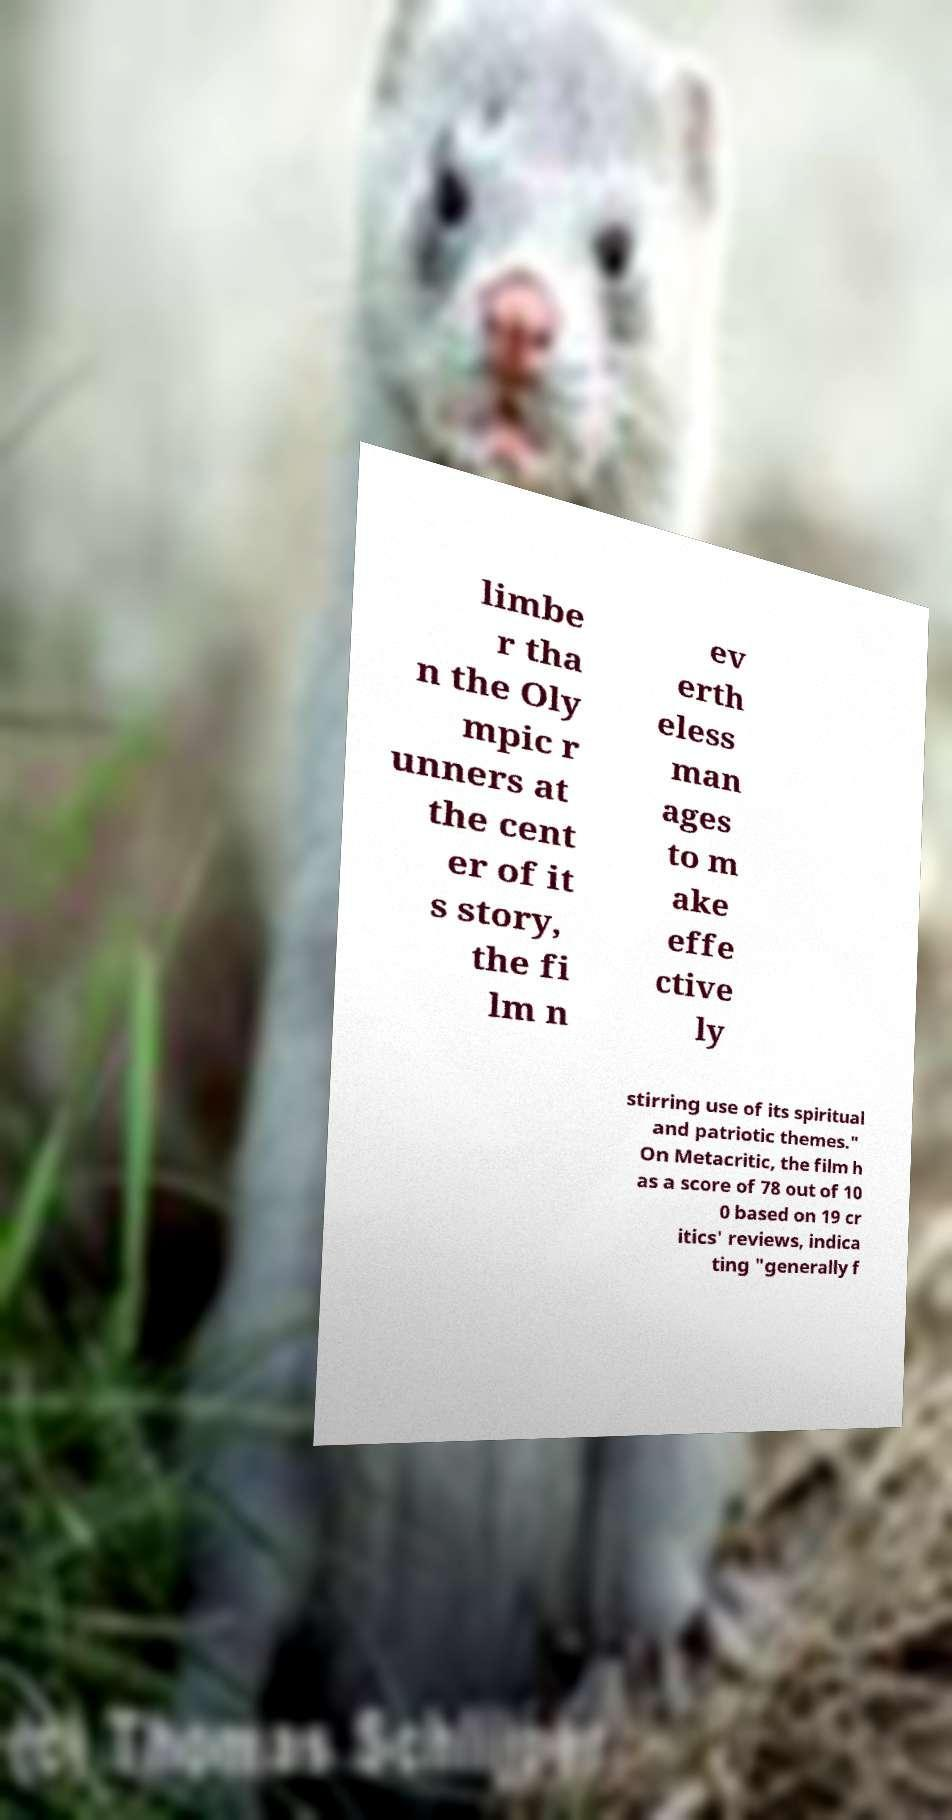Could you extract and type out the text from this image? limbe r tha n the Oly mpic r unners at the cent er of it s story, the fi lm n ev erth eless man ages to m ake effe ctive ly stirring use of its spiritual and patriotic themes." On Metacritic, the film h as a score of 78 out of 10 0 based on 19 cr itics' reviews, indica ting "generally f 